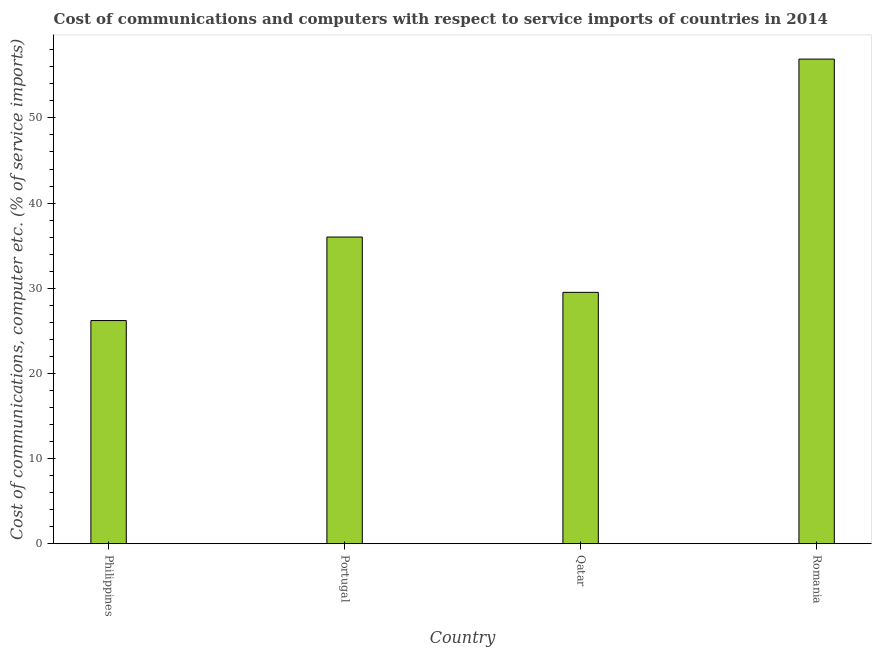Does the graph contain grids?
Ensure brevity in your answer.  No. What is the title of the graph?
Provide a short and direct response. Cost of communications and computers with respect to service imports of countries in 2014. What is the label or title of the X-axis?
Offer a terse response. Country. What is the label or title of the Y-axis?
Ensure brevity in your answer.  Cost of communications, computer etc. (% of service imports). What is the cost of communications and computer in Portugal?
Keep it short and to the point. 36.01. Across all countries, what is the maximum cost of communications and computer?
Offer a terse response. 56.91. Across all countries, what is the minimum cost of communications and computer?
Provide a succinct answer. 26.2. In which country was the cost of communications and computer maximum?
Your response must be concise. Romania. In which country was the cost of communications and computer minimum?
Your answer should be compact. Philippines. What is the sum of the cost of communications and computer?
Ensure brevity in your answer.  148.64. What is the difference between the cost of communications and computer in Portugal and Romania?
Give a very brief answer. -20.9. What is the average cost of communications and computer per country?
Provide a succinct answer. 37.16. What is the median cost of communications and computer?
Your response must be concise. 32.76. In how many countries, is the cost of communications and computer greater than 30 %?
Offer a very short reply. 2. What is the ratio of the cost of communications and computer in Philippines to that in Romania?
Provide a succinct answer. 0.46. Is the difference between the cost of communications and computer in Philippines and Portugal greater than the difference between any two countries?
Keep it short and to the point. No. What is the difference between the highest and the second highest cost of communications and computer?
Your answer should be compact. 20.9. What is the difference between the highest and the lowest cost of communications and computer?
Offer a terse response. 30.71. In how many countries, is the cost of communications and computer greater than the average cost of communications and computer taken over all countries?
Offer a terse response. 1. How many bars are there?
Your answer should be very brief. 4. Are all the bars in the graph horizontal?
Your answer should be compact. No. Are the values on the major ticks of Y-axis written in scientific E-notation?
Provide a succinct answer. No. What is the Cost of communications, computer etc. (% of service imports) in Philippines?
Keep it short and to the point. 26.2. What is the Cost of communications, computer etc. (% of service imports) of Portugal?
Give a very brief answer. 36.01. What is the Cost of communications, computer etc. (% of service imports) of Qatar?
Offer a very short reply. 29.51. What is the Cost of communications, computer etc. (% of service imports) in Romania?
Offer a terse response. 56.91. What is the difference between the Cost of communications, computer etc. (% of service imports) in Philippines and Portugal?
Your answer should be compact. -9.81. What is the difference between the Cost of communications, computer etc. (% of service imports) in Philippines and Qatar?
Ensure brevity in your answer.  -3.31. What is the difference between the Cost of communications, computer etc. (% of service imports) in Philippines and Romania?
Offer a very short reply. -30.71. What is the difference between the Cost of communications, computer etc. (% of service imports) in Portugal and Qatar?
Provide a short and direct response. 6.5. What is the difference between the Cost of communications, computer etc. (% of service imports) in Portugal and Romania?
Your answer should be compact. -20.9. What is the difference between the Cost of communications, computer etc. (% of service imports) in Qatar and Romania?
Your answer should be very brief. -27.39. What is the ratio of the Cost of communications, computer etc. (% of service imports) in Philippines to that in Portugal?
Offer a very short reply. 0.73. What is the ratio of the Cost of communications, computer etc. (% of service imports) in Philippines to that in Qatar?
Make the answer very short. 0.89. What is the ratio of the Cost of communications, computer etc. (% of service imports) in Philippines to that in Romania?
Offer a very short reply. 0.46. What is the ratio of the Cost of communications, computer etc. (% of service imports) in Portugal to that in Qatar?
Your response must be concise. 1.22. What is the ratio of the Cost of communications, computer etc. (% of service imports) in Portugal to that in Romania?
Offer a terse response. 0.63. What is the ratio of the Cost of communications, computer etc. (% of service imports) in Qatar to that in Romania?
Offer a very short reply. 0.52. 